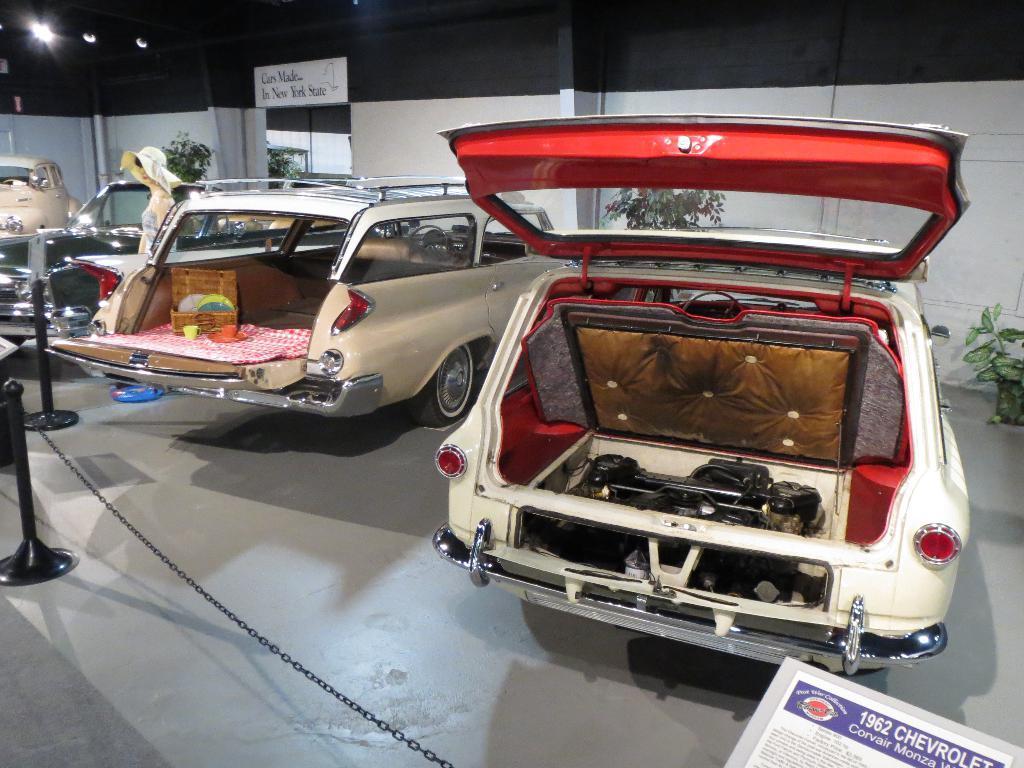Please provide a concise description of this image. In this image we can see motor vehicles on the floor. In addition to this we can see electric lights, house plants, walls, pipelines, woman standing on the floor, barrier poles and chains. 